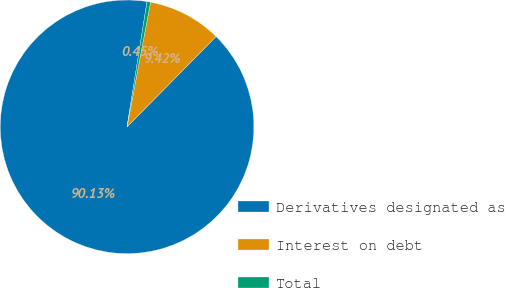Convert chart. <chart><loc_0><loc_0><loc_500><loc_500><pie_chart><fcel>Derivatives designated as<fcel>Interest on debt<fcel>Total<nl><fcel>90.13%<fcel>9.42%<fcel>0.45%<nl></chart> 